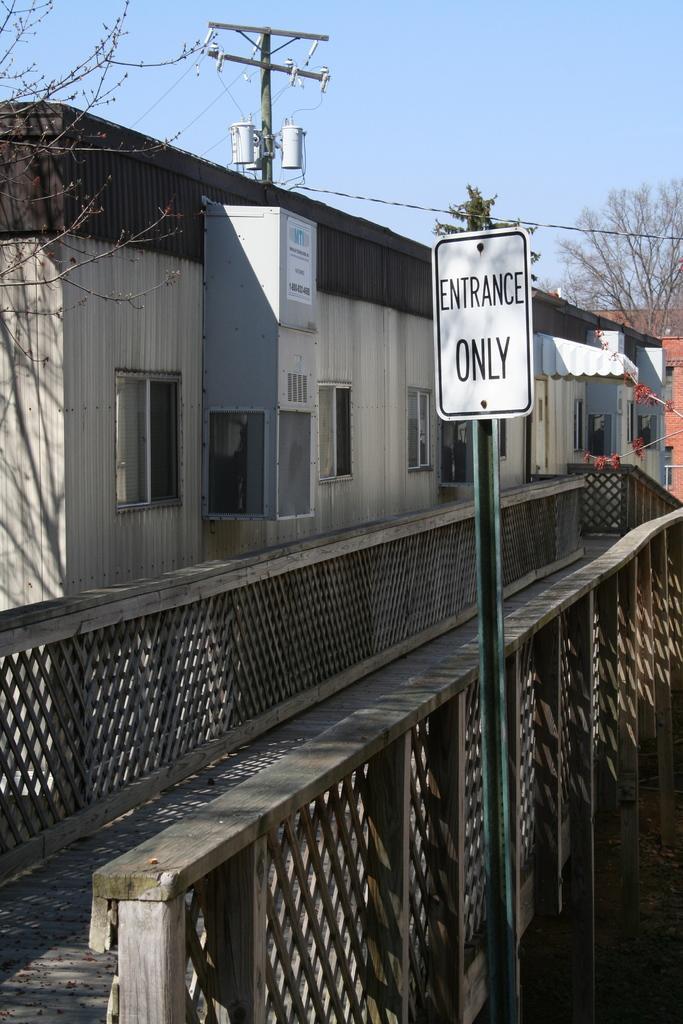In one or two sentences, can you explain what this image depicts? In this image there is a wooden bridge in the middle. Beside the bridge there is a building with the windows. Above the building there is an electric pole to which there are transformers. On the right side beside the bridge there is a pole with a board on it. In the background there are buildings and trees. At the top there is sky. 